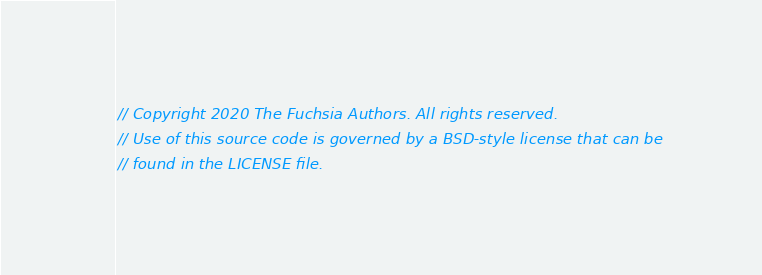Convert code to text. <code><loc_0><loc_0><loc_500><loc_500><_Rust_>// Copyright 2020 The Fuchsia Authors. All rights reserved.
// Use of this source code is governed by a BSD-style license that can be
// found in the LICENSE file.
</code> 